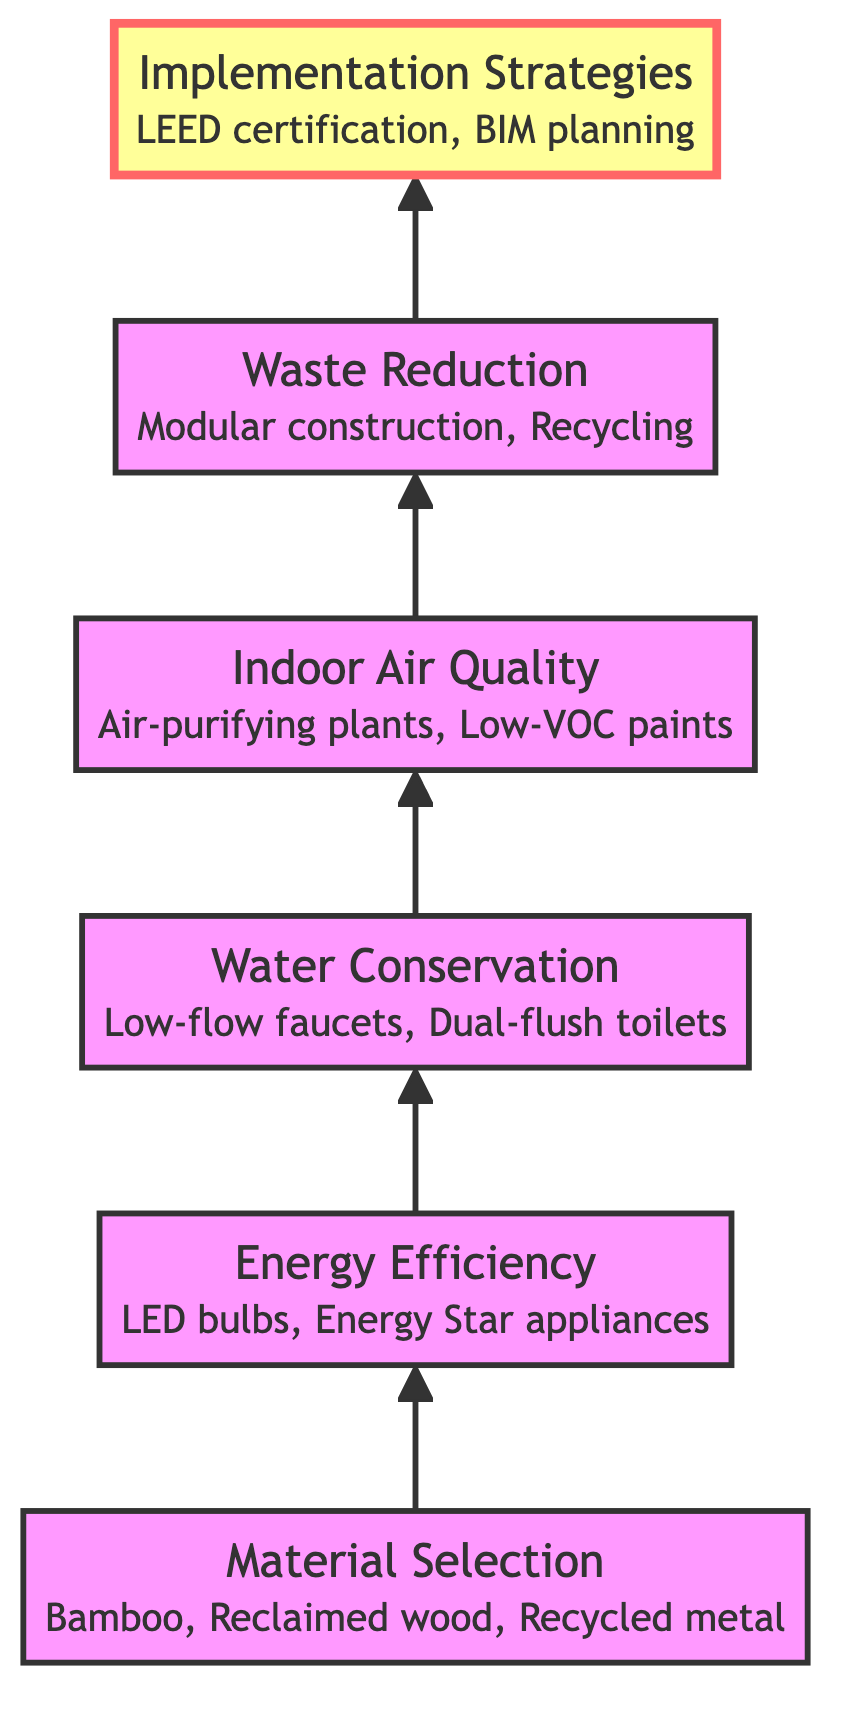What is the top element in the flow chart? The flow chart is structured with arrows pointing upwards, and the top element represents the final outcome of the sustainable design practices discussed. By examining the flowchart, the highest node is "Implementation Strategies."
Answer: Implementation Strategies How many nodes are there in total? The flow chart consists of distinct levels of information, each represented by a node. Counting all the levels, there are six nodes in total: Material Selection, Energy Efficiency, Water Conservation, Indoor Air Quality, Waste Reduction, and Implementation Strategies.
Answer: Six What is the relationship between Indoor Air Quality and Waste Reduction? To determine the relationship, we analyze the flow of the diagram. Indoor Air Quality is positioned directly before Waste Reduction, indicating that both are part of the sequential approach to sustainable design practices, with Waste Reduction building on the previous concepts.
Answer: Sequential What type of materials should be selected at the bottom node? The bottom node focuses on the foundational step of sustainable design, which is Material Selection. The node specifies choosing eco-friendly materials, exemplified by the options provided. Examining the node, eco-friendly materials such as bamboo, reclaimed wood, and recycled metal are specified.
Answer: Eco-friendly materials What is one example of energy-efficient elements mentioned in the flow chart? The Energy Efficiency node provides examples of elements that help reduce energy consumption. By reviewing the examples listed under this node, LED bulbs are clearly identified as a specific type of energy-efficient element.
Answer: LED bulbs Which element focuses on enhancing air quality? The element specifically emphasizing air quality is called Indoor Air Quality. This node is focused on methods and materials used to improve air quality in interior spaces, including plants and non-toxic materials.
Answer: Indoor Air Quality What practices are associated with the Implementation Strategies node? To answer this question, we need to reference the top node, Implementation Strategies, and the examples listed. This node mentions applying sustainable design principles cohesively, which involves practices such as integrated project delivery and LEED certification.
Answer: Sustainable design principles What is the second node in the flow chart? The flow chart is arranged from bottom to top, with each node representing a step or principle in sustainable design. The first node is Material Selection, followed by Energy Efficiency as the second node in the diagram.
Answer: Energy Efficiency How does Water Conservation relate to Indoor Air Quality? To understand the relationship, we look at the arrangement of the nodes. Water Conservation is placed directly before Indoor Air Quality in the upward flow, suggesting that strategies for conserving water might also contribute to maintaining indoor environmental standards related to air quality.
Answer: Sequential connection 